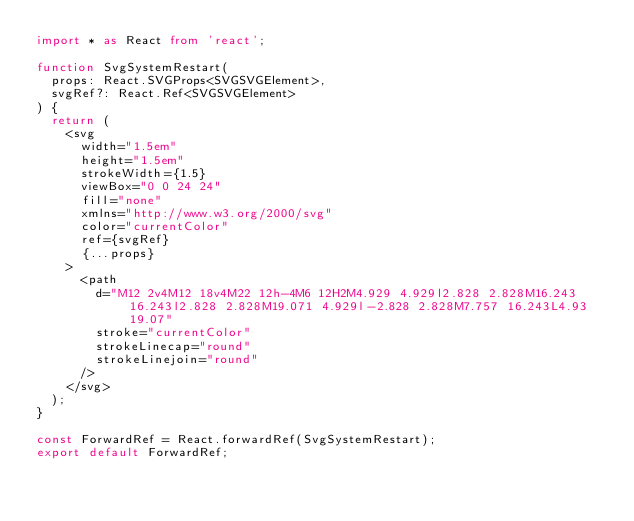Convert code to text. <code><loc_0><loc_0><loc_500><loc_500><_TypeScript_>import * as React from 'react';

function SvgSystemRestart(
  props: React.SVGProps<SVGSVGElement>,
  svgRef?: React.Ref<SVGSVGElement>
) {
  return (
    <svg
      width="1.5em"
      height="1.5em"
      strokeWidth={1.5}
      viewBox="0 0 24 24"
      fill="none"
      xmlns="http://www.w3.org/2000/svg"
      color="currentColor"
      ref={svgRef}
      {...props}
    >
      <path
        d="M12 2v4M12 18v4M22 12h-4M6 12H2M4.929 4.929l2.828 2.828M16.243 16.243l2.828 2.828M19.071 4.929l-2.828 2.828M7.757 16.243L4.93 19.07"
        stroke="currentColor"
        strokeLinecap="round"
        strokeLinejoin="round"
      />
    </svg>
  );
}

const ForwardRef = React.forwardRef(SvgSystemRestart);
export default ForwardRef;
</code> 